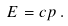Convert formula to latex. <formula><loc_0><loc_0><loc_500><loc_500>E = c p \, .</formula> 